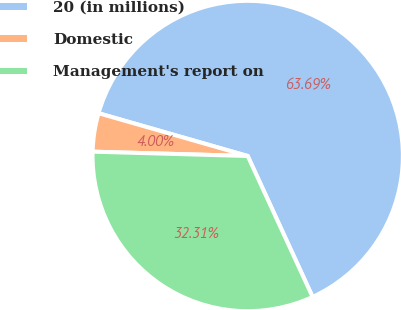Convert chart to OTSL. <chart><loc_0><loc_0><loc_500><loc_500><pie_chart><fcel>20 (in millions)<fcel>Domestic<fcel>Management's report on<nl><fcel>63.69%<fcel>4.0%<fcel>32.31%<nl></chart> 